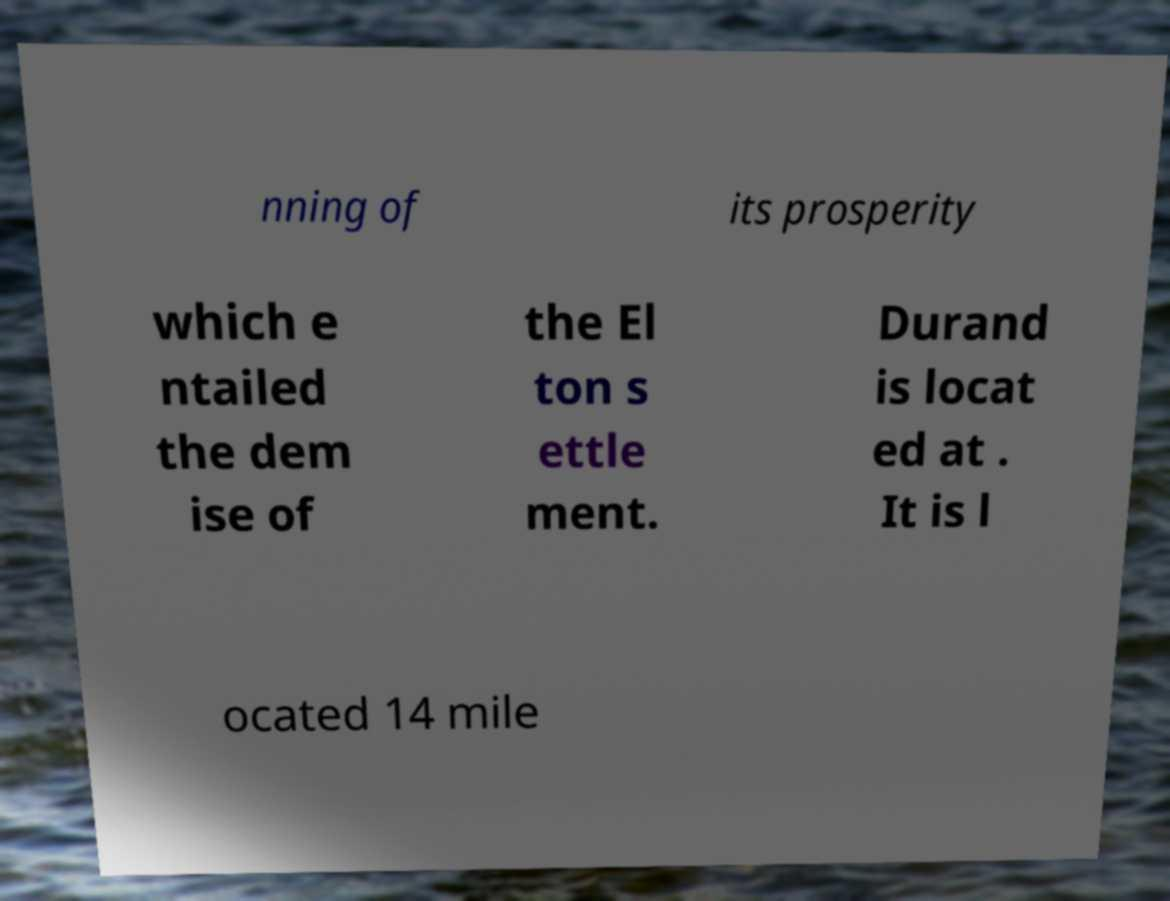I need the written content from this picture converted into text. Can you do that? nning of its prosperity which e ntailed the dem ise of the El ton s ettle ment. Durand is locat ed at . It is l ocated 14 mile 